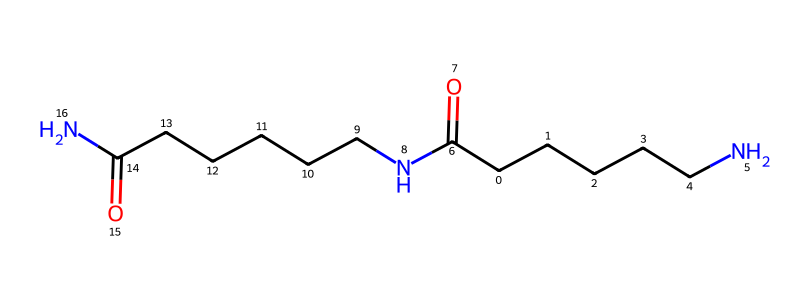What is the main functional group present in this chemical structure? The chemical structure contains the amide functional groups represented by the -C(=O)N- segments. This is characteristic of nylon.
Answer: amide How many carbon atoms are in the molecule? Count the carbon (C) symbols in the SMILES representation which shows a total of 12 carbon atoms in the structure of nylon-6,6.
Answer: 12 What type of polymer is represented by this structure? The presence of amide linkages (-C(=O)N-) and long carbon chains indicates that this is a polyamide polymer, specifically nylon-6,6.
Answer: polyamide How many nitrogen atoms does this chemical structure contain? The SMILES notation indicates 2 occurrences of 'N', which corresponds to two nitrogen atoms in the structure of nylon-6,6.
Answer: 2 What is the total number of bonds formed by carbon in this structure? Each carbon in this structure typically forms four bonds, and from the layout of the carbon atoms, counting their connections shows that they collectively form 22 bonds with other atoms.
Answer: 22 Is this chemical structure likely to be soluble in water? Polymers like nylon tend to be hydrophilic due to their amide groups, which can form hydrogen bonds with water, but the specific solubility can depend on factors such as molecular weight and conditions.
Answer: potentially What type of interactions would dominate in a fabric made from this polymer? The presence of hydrogen bonds between amide groups significantly contributes to the structural integrity and strength of nylon-6,6 fabrics, indicating these interactions prevail.
Answer: hydrogen bonds 